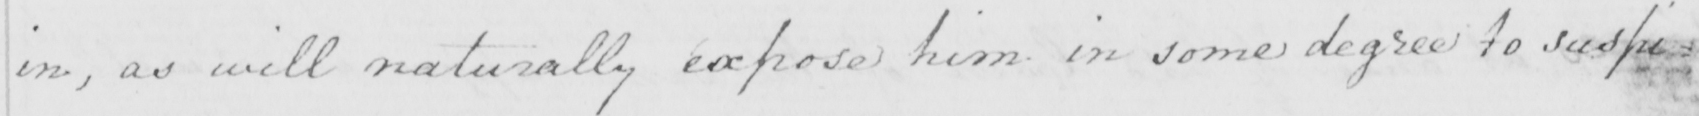Can you tell me what this handwritten text says? in , as will naturally expose him in some degree to suspi= 